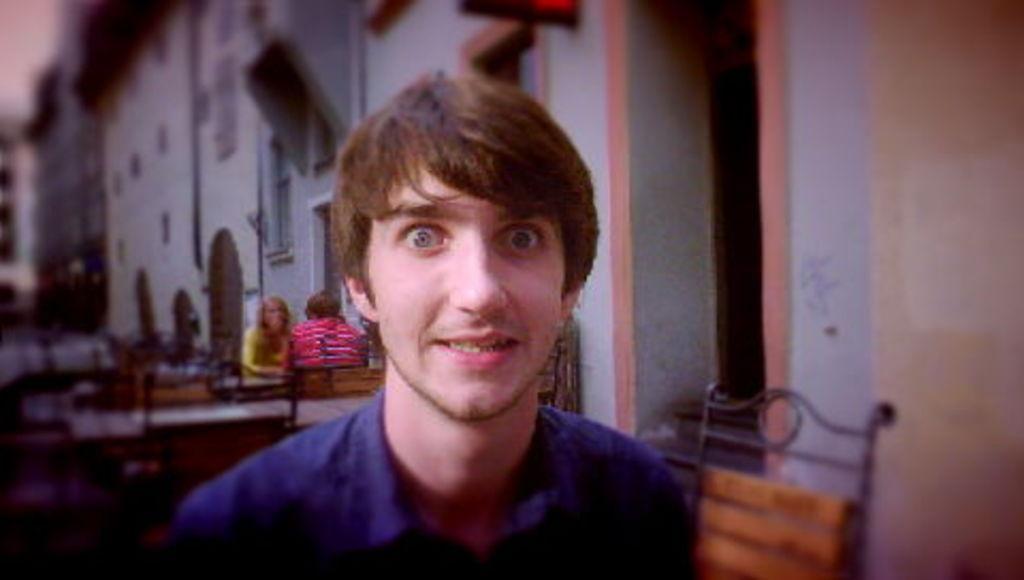Please provide a concise description of this image. In the center of the image a man is there. In the background of the image we can see some persons, tables, chairs, buildings, door, windows, wall are there. 